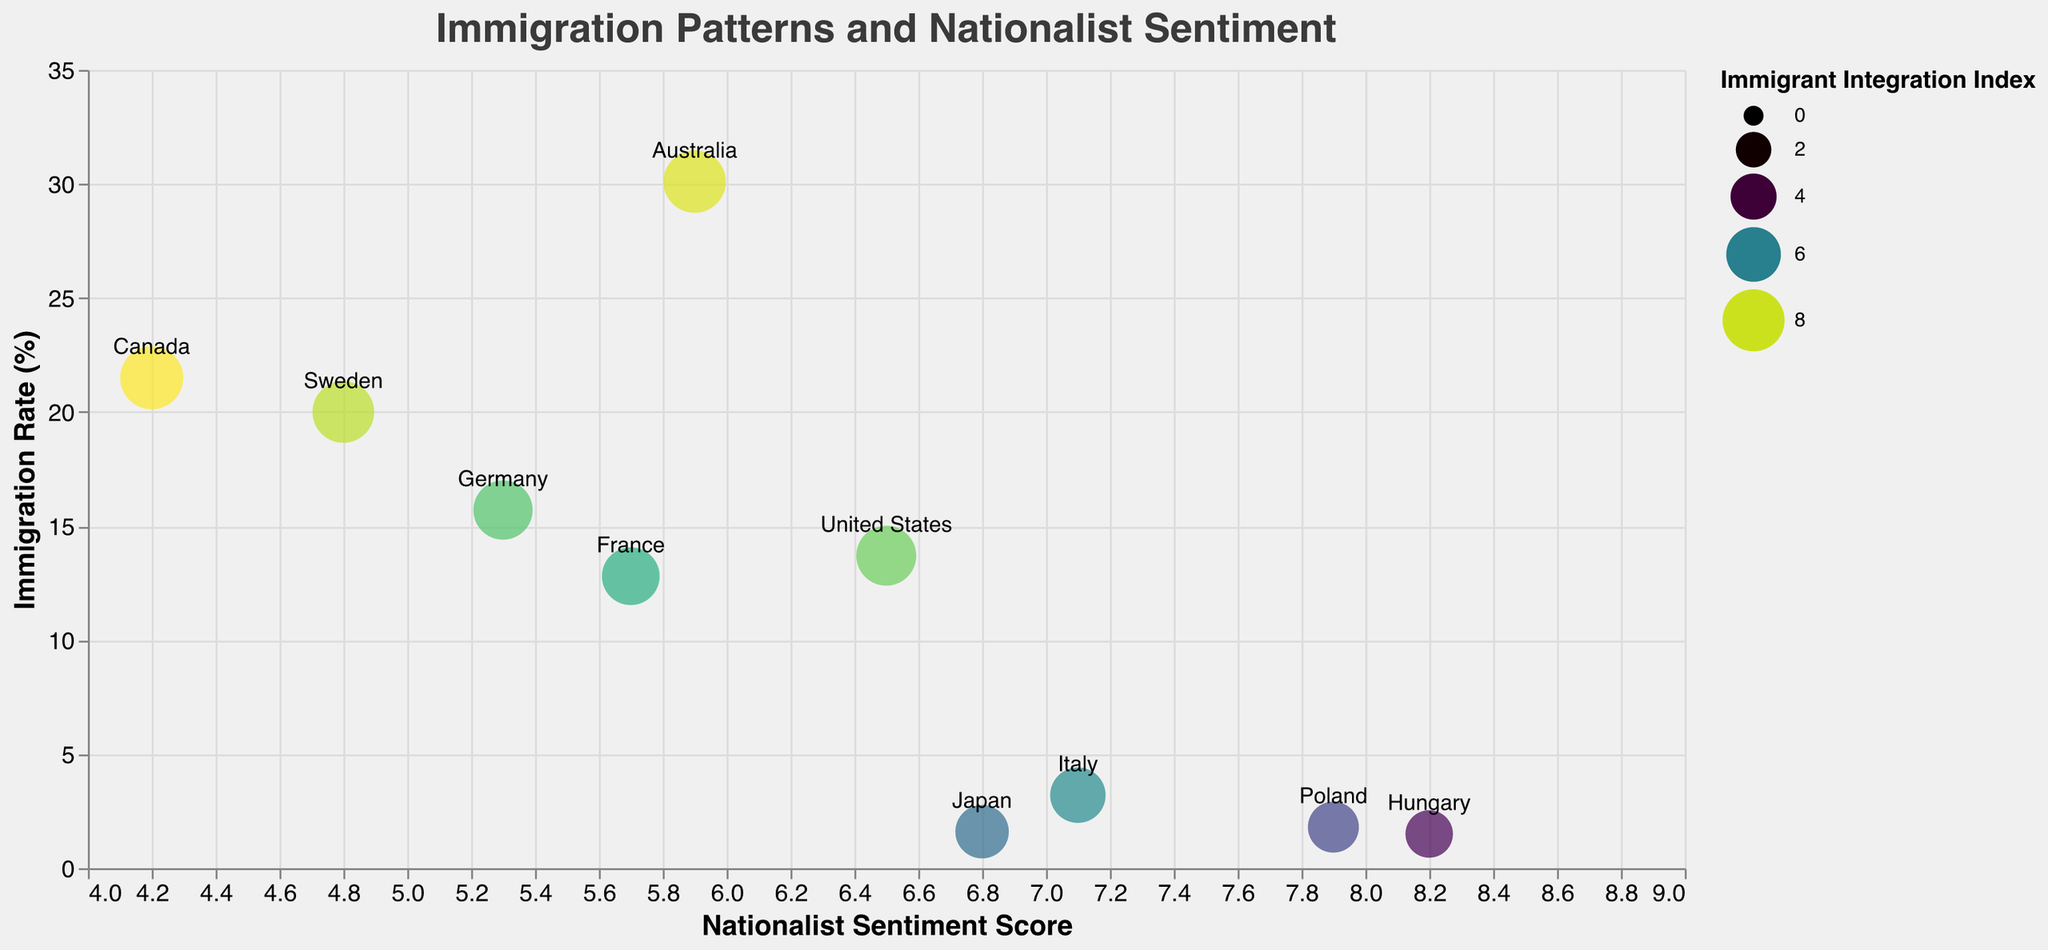What is the title of the figure? The title is prominently displayed at the top of the figure with a font size larger than other text elements. It reads "Immigration Patterns and Nationalist Sentiment".
Answer: Immigration Patterns and Nationalist Sentiment Which country has the highest immigration rate? By examining the y-axis representing Immigration Rate (%) and identifying the highest point on the graph, we can see Australia has the highest immigration rate at 30.1%.
Answer: Australia What is the relationship between Nationalist Sentiment Score and Immigration Rate for Japan? Locate Japan on the figure and note its position along the x-axis (Nationalist Sentiment Score) and y-axis (Immigration Rate). Japan has a Nationalist Sentiment Score of 6.8 and an Immigration Rate of 1.6%.
Answer: 6.8 (Sentiment Score), 1.6% (Immigration Rate) Which country shows the highest Immigrant Integration Index? Identify the point with the largest circle size, which corresponds to the highest Immigrant Integration Index. Canada has the largest circle size and an Immigrant Integration Index of 8.3.
Answer: Canada Compare the Immigration Rate and Nationalist Sentiment Score between France and Germany. Locate France and Germany on the figure, note their positions along both axes. France: Immigration Rate 12.8%, Nationalist Sentiment Score 5.7. Germany: Immigration Rate 15.7%, Nationalist Sentiment Score 5.3. Germany has a higher Immigration Rate but a slightly lower Nationalist Sentiment Score compared to France.
Answer: Germany higher Immigration Rate, France higher Nationalist Sentiment Score How many countries have a Nationalist Sentiment Score greater than 6? Identify points along the x-axis with Nationalist Sentiment Scores greater than 6. Countries: Hungary (8.2), Poland (7.9), Italy (7.1), Japan (6.8), United States (6.5). There are 5 countries.
Answer: 5 countries What is the average Immigration Rate of countries with Nationalist Sentiment Score below 5? Identify the countries with Nationalist Sentiment Scores below 5: Sweden (4.8) and Canada (4.2). Calculate their average Immigration Rate: (20.0 + 21.5) / 2 = 20.75.
Answer: 20.75% What is the most common origin of immigrants among the countries displayed? Read the tooltip information for each country noting the "Top Immigrant Origin". Romania (appears for Hungary and Italy) is the most common origin among the displayed countries.
Answer: Romania Which country has the lowest Nationalist Sentiment Score and what is their Immigration Rate? Identify the point with the lowest position along the x-axis. Canada has the lowest Nationalist Sentiment Score of 4.2 and an Immigration Rate of 21.5%.
Answer: Canada, 21.5% Explain the distribution trend of Immigration Rates in relation to Nationalist Sentiment Scores. Observe the overall pattern of points on the graph. Countries with higher Nationalist Sentiment Scores tend to have lower Immigration Rates, while those with lower Nationalist Sentiment Scores have higher Immigration Rates. This suggests an inverse relationship between Nationalist Sentiment Score and Immigration Rate.
Answer: Inverse relationship 